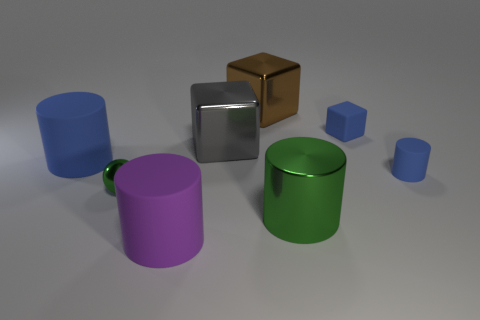Add 1 small brown cylinders. How many objects exist? 9 Subtract all shiny blocks. How many blocks are left? 1 Subtract all brown balls. How many blue cylinders are left? 2 Subtract all purple cylinders. How many cylinders are left? 3 Subtract 2 cylinders. How many cylinders are left? 2 Subtract all green blocks. Subtract all brown cylinders. How many blocks are left? 3 Subtract all spheres. How many objects are left? 7 Subtract all red metallic cubes. Subtract all purple cylinders. How many objects are left? 7 Add 3 green shiny cylinders. How many green shiny cylinders are left? 4 Add 8 green balls. How many green balls exist? 9 